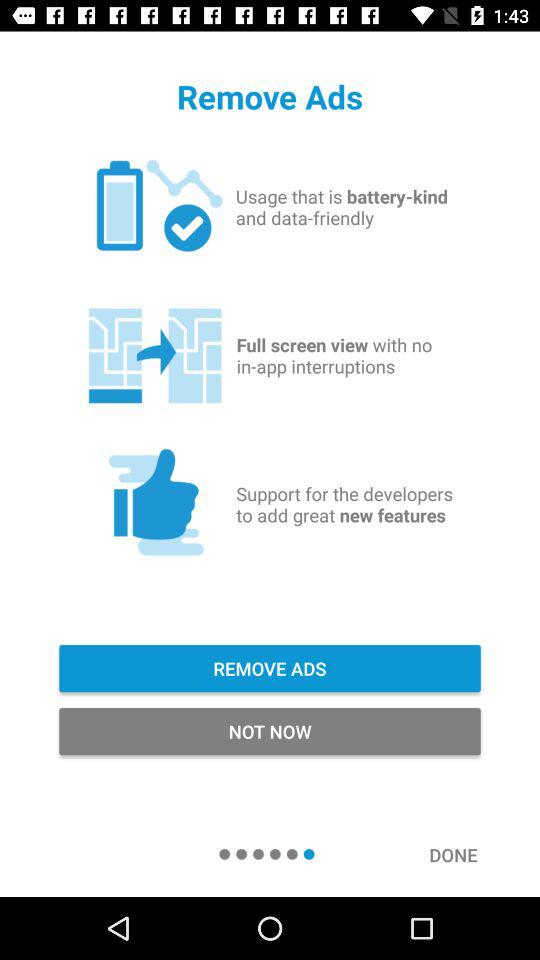How many features does the user get when they remove ads?
Answer the question using a single word or phrase. 3 